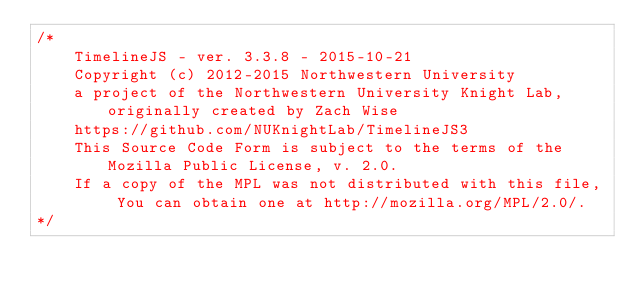Convert code to text. <code><loc_0><loc_0><loc_500><loc_500><_CSS_>/*
    TimelineJS - ver. 3.3.8 - 2015-10-21
    Copyright (c) 2012-2015 Northwestern University
    a project of the Northwestern University Knight Lab, originally created by Zach Wise
    https://github.com/NUKnightLab/TimelineJS3
    This Source Code Form is subject to the terms of the Mozilla Public License, v. 2.0.
    If a copy of the MPL was not distributed with this file, You can obtain one at http://mozilla.org/MPL/2.0/.
*/</code> 